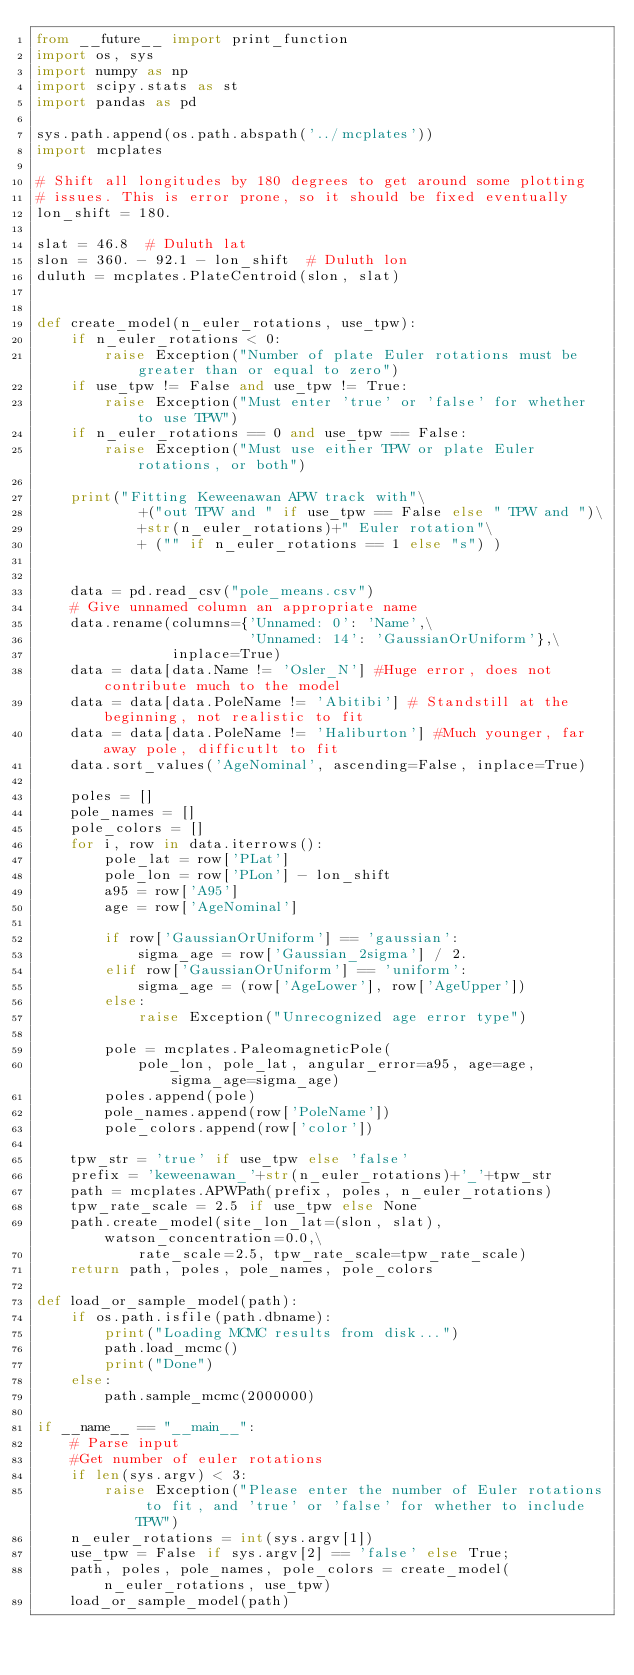Convert code to text. <code><loc_0><loc_0><loc_500><loc_500><_Python_>from __future__ import print_function
import os, sys
import numpy as np
import scipy.stats as st
import pandas as pd

sys.path.append(os.path.abspath('../mcplates'))
import mcplates

# Shift all longitudes by 180 degrees to get around some plotting
# issues. This is error prone, so it should be fixed eventually
lon_shift = 180.

slat = 46.8  # Duluth lat
slon = 360. - 92.1 - lon_shift  # Duluth lon
duluth = mcplates.PlateCentroid(slon, slat)


def create_model(n_euler_rotations, use_tpw):
    if n_euler_rotations < 0:
        raise Exception("Number of plate Euler rotations must be greater than or equal to zero")
    if use_tpw != False and use_tpw != True:
        raise Exception("Must enter 'true' or 'false' for whether to use TPW")
    if n_euler_rotations == 0 and use_tpw == False:
        raise Exception("Must use either TPW or plate Euler rotations, or both")

    print("Fitting Keweenawan APW track with"\
            +("out TPW and " if use_tpw == False else " TPW and ")\
            +str(n_euler_rotations)+" Euler rotation"\
            + ("" if n_euler_rotations == 1 else "s") )


    data = pd.read_csv("pole_means.csv")
    # Give unnamed column an appropriate name
    data.rename(columns={'Unnamed: 0': 'Name',\
                         'Unnamed: 14': 'GaussianOrUniform'},\
                inplace=True)
    data = data[data.Name != 'Osler_N'] #Huge error, does not contribute much to the model
    data = data[data.PoleName != 'Abitibi'] # Standstill at the beginning, not realistic to fit
    data = data[data.PoleName != 'Haliburton'] #Much younger, far away pole, difficutlt to fit
    data.sort_values('AgeNominal', ascending=False, inplace=True)

    poles = []
    pole_names = []
    pole_colors = []
    for i, row in data.iterrows():
        pole_lat = row['PLat']
        pole_lon = row['PLon'] - lon_shift
        a95 = row['A95']
        age = row['AgeNominal']

        if row['GaussianOrUniform'] == 'gaussian':
            sigma_age = row['Gaussian_2sigma'] / 2.
        elif row['GaussianOrUniform'] == 'uniform':
            sigma_age = (row['AgeLower'], row['AgeUpper'])
        else:
            raise Exception("Unrecognized age error type")

        pole = mcplates.PaleomagneticPole(
            pole_lon, pole_lat, angular_error=a95, age=age, sigma_age=sigma_age)
        poles.append(pole)
        pole_names.append(row['PoleName'])
        pole_colors.append(row['color'])

    tpw_str = 'true' if use_tpw else 'false'
    prefix = 'keweenawan_'+str(n_euler_rotations)+'_'+tpw_str
    path = mcplates.APWPath(prefix, poles, n_euler_rotations)
    tpw_rate_scale = 2.5 if use_tpw else None
    path.create_model(site_lon_lat=(slon, slat), watson_concentration=0.0,\
            rate_scale=2.5, tpw_rate_scale=tpw_rate_scale)
    return path, poles, pole_names, pole_colors

def load_or_sample_model(path):
    if os.path.isfile(path.dbname):
        print("Loading MCMC results from disk...")
        path.load_mcmc()
        print("Done")
    else:
        path.sample_mcmc(2000000)

if __name__ == "__main__":
    # Parse input
    #Get number of euler rotations
    if len(sys.argv) < 3:
        raise Exception("Please enter the number of Euler rotations to fit, and 'true' or 'false' for whether to include TPW")
    n_euler_rotations = int(sys.argv[1])
    use_tpw = False if sys.argv[2] == 'false' else True;
    path, poles, pole_names, pole_colors = create_model(n_euler_rotations, use_tpw)
    load_or_sample_model(path)
</code> 